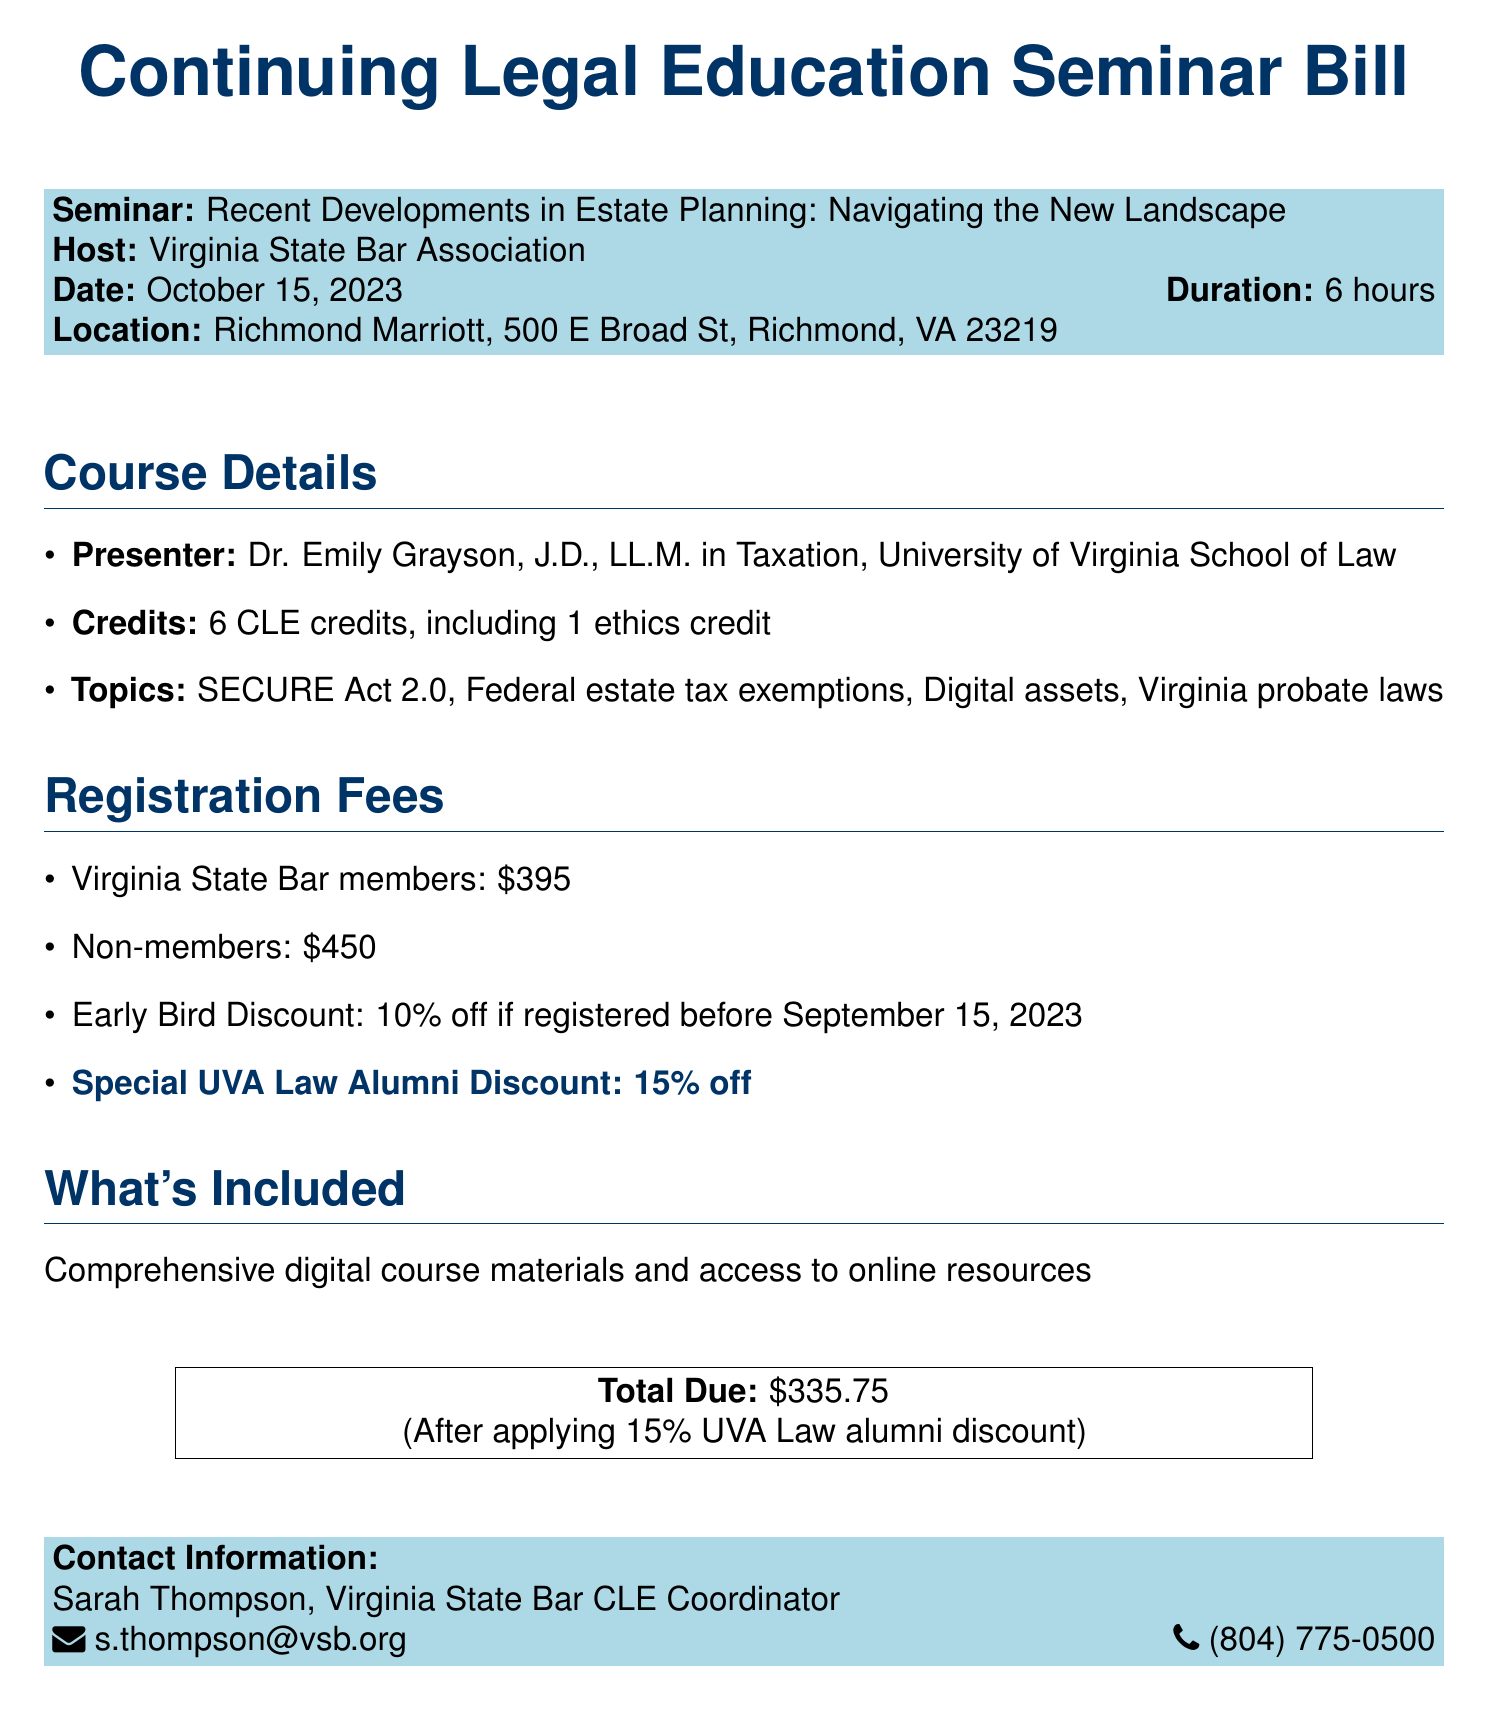What is the seminar title? The seminar title is mentioned in the document and is "Recent Developments in Estate Planning: Navigating the New Landscape."
Answer: Recent Developments in Estate Planning: Navigating the New Landscape Who is the presenter? The presenter is specified in the document as Dr. Emily Grayson, J.D., LL.M. in Taxation.
Answer: Dr. Emily Grayson, J.D., LL.M. in Taxation How many CLE credits are offered? The document states that 6 CLE credits are offered for the seminar.
Answer: 6 credits What is the early bird discount percentage? The early bird discount percentage is mentioned as 10% for registrations before September 15, 2023.
Answer: 10% What is the total amount due after applying the UVA Law alumni discount? The total amount due after the special discount is calculated in the document and is $335.75.
Answer: $335.75 What date is the seminar scheduled for? The seminar date is explicitly given in the document as October 15, 2023.
Answer: October 15, 2023 How long is the duration of the seminar? The duration of the seminar is stated as 6 hours in the document.
Answer: 6 hours What is the location of the seminar? The location where the seminar will be held is specified as Richmond Marriott, 500 E Broad St, Richmond, VA 23219.
Answer: Richmond Marriott, 500 E Broad St, Richmond, VA 23219 What is the special discount for UVA Law alumni? The document mentions that there is a special discount of 15% for UVA Law alumni.
Answer: 15% off 